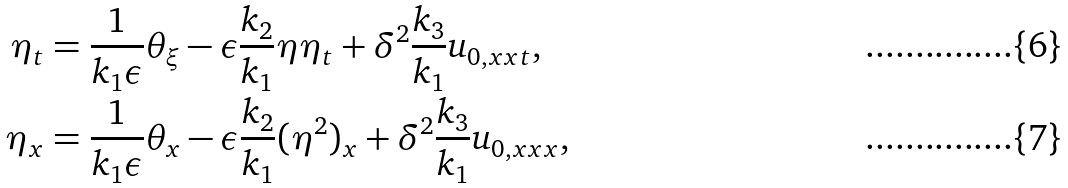<formula> <loc_0><loc_0><loc_500><loc_500>\eta _ { t } & = \frac { 1 } { k _ { 1 } \epsilon } \theta _ { \xi } - \epsilon \frac { k _ { 2 } } { k _ { 1 } } \eta \eta _ { t } + \delta ^ { 2 } \frac { k _ { 3 } } { k _ { 1 } } u _ { 0 , x x t } , \\ \eta _ { x } & = \frac { 1 } { k _ { 1 } \epsilon } \theta _ { x } - \epsilon \frac { k _ { 2 } } { k _ { 1 } } ( \eta ^ { 2 } ) _ { x } + \delta ^ { 2 } \frac { k _ { 3 } } { k _ { 1 } } u _ { 0 , x x x } ,</formula> 